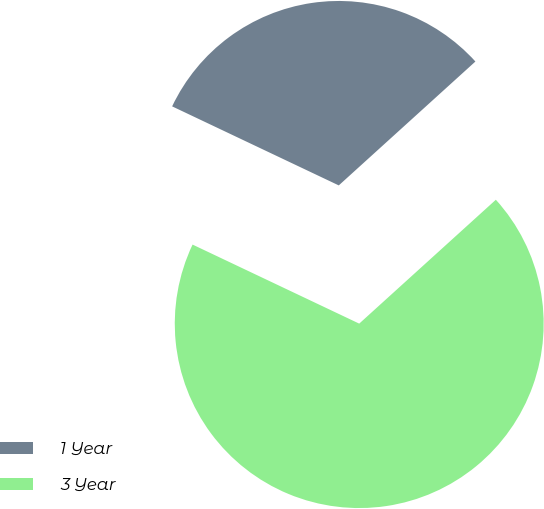<chart> <loc_0><loc_0><loc_500><loc_500><pie_chart><fcel>1 Year<fcel>3 Year<nl><fcel>31.23%<fcel>68.77%<nl></chart> 